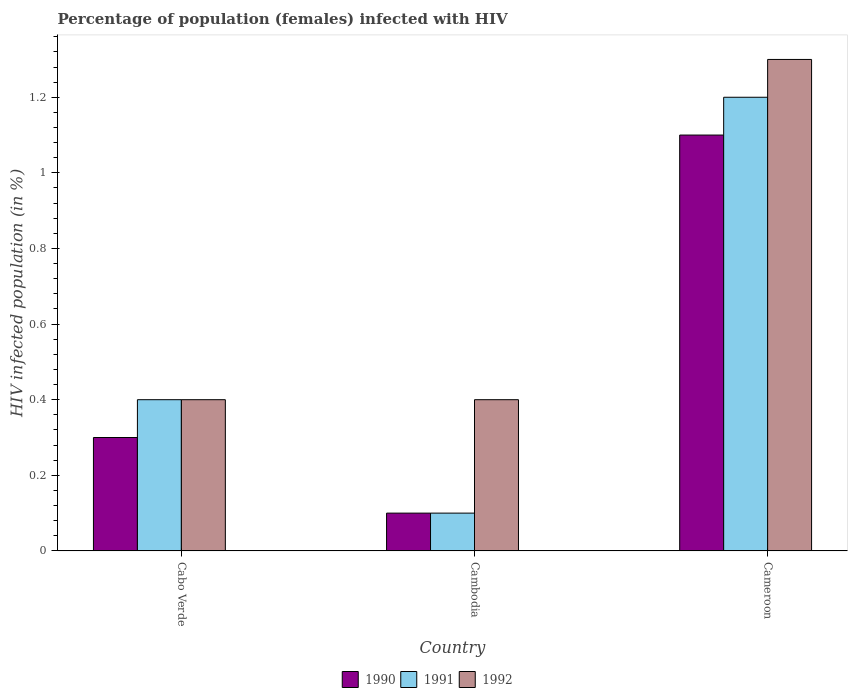How many different coloured bars are there?
Ensure brevity in your answer.  3. How many groups of bars are there?
Ensure brevity in your answer.  3. Are the number of bars per tick equal to the number of legend labels?
Give a very brief answer. Yes. How many bars are there on the 3rd tick from the left?
Give a very brief answer. 3. What is the label of the 3rd group of bars from the left?
Provide a short and direct response. Cameroon. Across all countries, what is the minimum percentage of HIV infected female population in 1991?
Offer a terse response. 0.1. In which country was the percentage of HIV infected female population in 1991 maximum?
Your response must be concise. Cameroon. In which country was the percentage of HIV infected female population in 1991 minimum?
Provide a succinct answer. Cambodia. What is the difference between the percentage of HIV infected female population in 1991 in Cabo Verde and that in Cameroon?
Keep it short and to the point. -0.8. What is the difference between the percentage of HIV infected female population in 1992 in Cambodia and the percentage of HIV infected female population in 1991 in Cameroon?
Provide a short and direct response. -0.8. What is the average percentage of HIV infected female population in 1991 per country?
Give a very brief answer. 0.57. What is the difference between the percentage of HIV infected female population of/in 1991 and percentage of HIV infected female population of/in 1990 in Cabo Verde?
Offer a terse response. 0.1. What is the ratio of the percentage of HIV infected female population in 1991 in Cabo Verde to that in Cambodia?
Offer a terse response. 4. Is the difference between the percentage of HIV infected female population in 1991 in Cambodia and Cameroon greater than the difference between the percentage of HIV infected female population in 1990 in Cambodia and Cameroon?
Offer a very short reply. No. What is the difference between the highest and the lowest percentage of HIV infected female population in 1990?
Make the answer very short. 1. In how many countries, is the percentage of HIV infected female population in 1990 greater than the average percentage of HIV infected female population in 1990 taken over all countries?
Offer a terse response. 1. Is the sum of the percentage of HIV infected female population in 1992 in Cabo Verde and Cambodia greater than the maximum percentage of HIV infected female population in 1990 across all countries?
Offer a very short reply. No. What does the 2nd bar from the left in Cameroon represents?
Your response must be concise. 1991. Is it the case that in every country, the sum of the percentage of HIV infected female population in 1991 and percentage of HIV infected female population in 1992 is greater than the percentage of HIV infected female population in 1990?
Your response must be concise. Yes. How many bars are there?
Provide a short and direct response. 9. Are all the bars in the graph horizontal?
Offer a terse response. No. What is the difference between two consecutive major ticks on the Y-axis?
Offer a very short reply. 0.2. Are the values on the major ticks of Y-axis written in scientific E-notation?
Give a very brief answer. No. How are the legend labels stacked?
Offer a very short reply. Horizontal. What is the title of the graph?
Offer a terse response. Percentage of population (females) infected with HIV. What is the label or title of the X-axis?
Keep it short and to the point. Country. What is the label or title of the Y-axis?
Make the answer very short. HIV infected population (in %). What is the HIV infected population (in %) of 1991 in Cabo Verde?
Provide a succinct answer. 0.4. What is the HIV infected population (in %) in 1990 in Cameroon?
Your answer should be very brief. 1.1. Across all countries, what is the maximum HIV infected population (in %) of 1990?
Your answer should be compact. 1.1. Across all countries, what is the maximum HIV infected population (in %) in 1991?
Provide a short and direct response. 1.2. Across all countries, what is the maximum HIV infected population (in %) in 1992?
Offer a very short reply. 1.3. Across all countries, what is the minimum HIV infected population (in %) of 1990?
Your answer should be compact. 0.1. Across all countries, what is the minimum HIV infected population (in %) in 1992?
Provide a succinct answer. 0.4. What is the total HIV infected population (in %) of 1990 in the graph?
Your answer should be compact. 1.5. What is the difference between the HIV infected population (in %) in 1990 in Cabo Verde and that in Cambodia?
Provide a succinct answer. 0.2. What is the difference between the HIV infected population (in %) of 1990 in Cabo Verde and that in Cameroon?
Give a very brief answer. -0.8. What is the difference between the HIV infected population (in %) in 1990 in Cambodia and that in Cameroon?
Offer a very short reply. -1. What is the difference between the HIV infected population (in %) in 1992 in Cambodia and that in Cameroon?
Your answer should be compact. -0.9. What is the difference between the HIV infected population (in %) of 1990 in Cabo Verde and the HIV infected population (in %) of 1992 in Cambodia?
Ensure brevity in your answer.  -0.1. What is the difference between the HIV infected population (in %) of 1991 in Cabo Verde and the HIV infected population (in %) of 1992 in Cambodia?
Keep it short and to the point. 0. What is the difference between the HIV infected population (in %) of 1990 in Cabo Verde and the HIV infected population (in %) of 1991 in Cameroon?
Provide a succinct answer. -0.9. What is the difference between the HIV infected population (in %) in 1990 in Cabo Verde and the HIV infected population (in %) in 1992 in Cameroon?
Ensure brevity in your answer.  -1. What is the difference between the HIV infected population (in %) of 1990 in Cambodia and the HIV infected population (in %) of 1991 in Cameroon?
Provide a short and direct response. -1.1. What is the difference between the HIV infected population (in %) in 1990 in Cambodia and the HIV infected population (in %) in 1992 in Cameroon?
Offer a terse response. -1.2. What is the average HIV infected population (in %) in 1991 per country?
Keep it short and to the point. 0.57. What is the average HIV infected population (in %) of 1992 per country?
Ensure brevity in your answer.  0.7. What is the difference between the HIV infected population (in %) of 1990 and HIV infected population (in %) of 1991 in Cabo Verde?
Give a very brief answer. -0.1. What is the difference between the HIV infected population (in %) of 1991 and HIV infected population (in %) of 1992 in Cabo Verde?
Offer a terse response. 0. What is the difference between the HIV infected population (in %) of 1990 and HIV infected population (in %) of 1991 in Cambodia?
Offer a terse response. 0. What is the difference between the HIV infected population (in %) of 1991 and HIV infected population (in %) of 1992 in Cambodia?
Make the answer very short. -0.3. What is the difference between the HIV infected population (in %) of 1990 and HIV infected population (in %) of 1991 in Cameroon?
Provide a short and direct response. -0.1. What is the difference between the HIV infected population (in %) in 1991 and HIV infected population (in %) in 1992 in Cameroon?
Offer a very short reply. -0.1. What is the ratio of the HIV infected population (in %) of 1991 in Cabo Verde to that in Cambodia?
Make the answer very short. 4. What is the ratio of the HIV infected population (in %) of 1990 in Cabo Verde to that in Cameroon?
Give a very brief answer. 0.27. What is the ratio of the HIV infected population (in %) in 1992 in Cabo Verde to that in Cameroon?
Offer a terse response. 0.31. What is the ratio of the HIV infected population (in %) in 1990 in Cambodia to that in Cameroon?
Provide a short and direct response. 0.09. What is the ratio of the HIV infected population (in %) in 1991 in Cambodia to that in Cameroon?
Your answer should be very brief. 0.08. What is the ratio of the HIV infected population (in %) in 1992 in Cambodia to that in Cameroon?
Your answer should be compact. 0.31. What is the difference between the highest and the second highest HIV infected population (in %) of 1990?
Offer a terse response. 0.8. What is the difference between the highest and the second highest HIV infected population (in %) of 1991?
Ensure brevity in your answer.  0.8. What is the difference between the highest and the lowest HIV infected population (in %) in 1990?
Offer a terse response. 1. What is the difference between the highest and the lowest HIV infected population (in %) in 1992?
Provide a short and direct response. 0.9. 